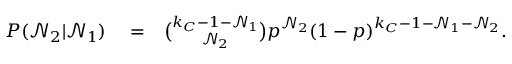<formula> <loc_0><loc_0><loc_500><loc_500>\begin{array} { r l r } { P ( \mathcal { N } _ { 2 } | \mathcal { N } _ { 1 } ) } & = } & { \binom { k _ { C } - 1 - \mathcal { N } _ { 1 } } { \mathcal { N } _ { 2 } } p ^ { \mathcal { N } _ { 2 } } ( 1 - p ) ^ { k _ { C } - 1 - \mathcal { N } _ { 1 } - \mathcal { N } _ { 2 } } . } \end{array}</formula> 